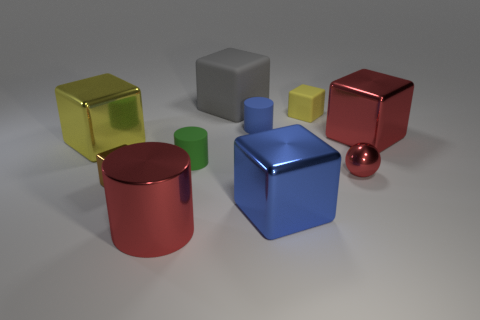There is a blue metallic object that is the same shape as the brown thing; what size is it?
Give a very brief answer. Large. How many other objects are there of the same color as the large cylinder?
Offer a very short reply. 2. Do the small metallic sphere and the big cylinder have the same color?
Ensure brevity in your answer.  Yes. What shape is the big red thing in front of the big metallic block that is behind the big yellow shiny object?
Your answer should be very brief. Cylinder. There is a big metallic thing to the right of the small yellow object; how many big red metal objects are to the left of it?
Make the answer very short. 1. There is a object that is both behind the tiny ball and to the left of the large metal cylinder; what is it made of?
Keep it short and to the point. Metal. What shape is the brown metal object that is the same size as the blue matte thing?
Ensure brevity in your answer.  Cube. What is the color of the rubber cylinder right of the large object behind the metallic object that is right of the red sphere?
Your response must be concise. Blue. What number of objects are either shiny cubes that are on the right side of the metal cylinder or rubber blocks?
Provide a short and direct response. 4. There is a red thing that is the same size as the blue matte thing; what is its material?
Provide a succinct answer. Metal. 